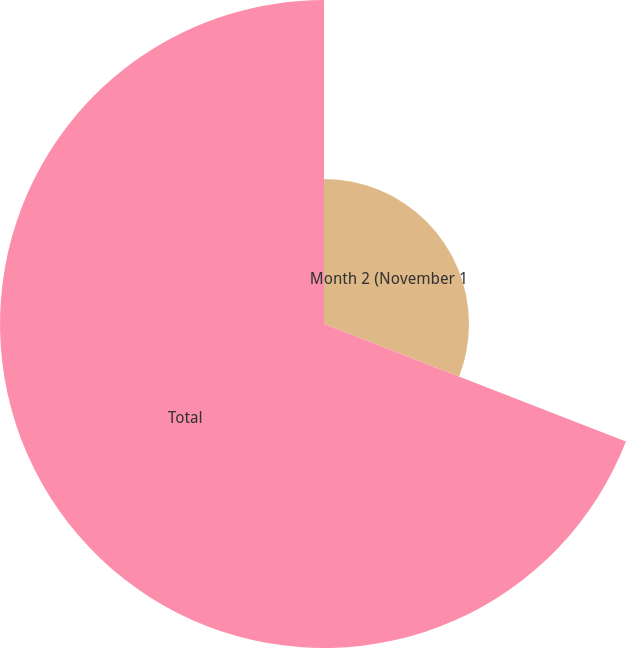<chart> <loc_0><loc_0><loc_500><loc_500><pie_chart><fcel>Month 2 (November 1<fcel>Total<nl><fcel>30.91%<fcel>69.09%<nl></chart> 